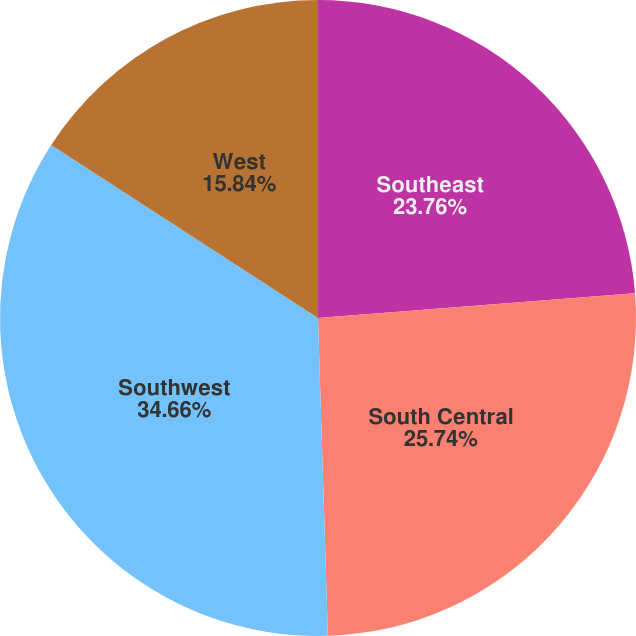Convert chart. <chart><loc_0><loc_0><loc_500><loc_500><pie_chart><fcel>Southeast<fcel>South Central<fcel>Southwest<fcel>West<nl><fcel>23.76%<fcel>25.74%<fcel>34.65%<fcel>15.84%<nl></chart> 